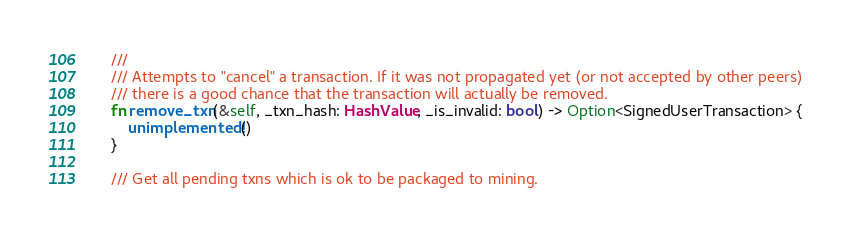<code> <loc_0><loc_0><loc_500><loc_500><_Rust_>    ///
    /// Attempts to "cancel" a transaction. If it was not propagated yet (or not accepted by other peers)
    /// there is a good chance that the transaction will actually be removed.
    fn remove_txn(&self, _txn_hash: HashValue, _is_invalid: bool) -> Option<SignedUserTransaction> {
        unimplemented!()
    }

    /// Get all pending txns which is ok to be packaged to mining.</code> 